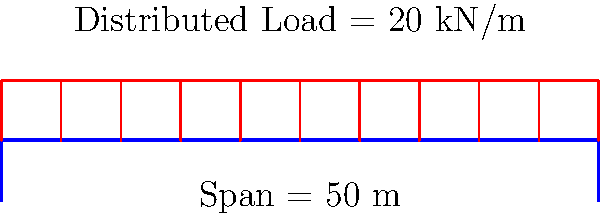As a former football coach, you're helping plan a parade route for your team's championship celebration. The route includes crossing a simple beam bridge. Given a bridge span of 50 meters and a uniform distributed load of 20 kN/m (including the weight of the bridge and the parade participants), what is the maximum bending moment at the center of the bridge? Let's approach this step-by-step:

1) For a simple beam bridge with a uniformly distributed load, the maximum bending moment occurs at the center of the span.

2) The formula for the maximum bending moment (M) in this case is:

   $$M = \frac{wL^2}{8}$$

   Where:
   w = distributed load (kN/m)
   L = span length (m)

3) We're given:
   w = 20 kN/m
   L = 50 m

4) Let's substitute these values into our formula:

   $$M = \frac{20 \cdot 50^2}{8}$$

5) Now, let's calculate:

   $$M = \frac{20 \cdot 2500}{8} = \frac{50000}{8} = 6250$$

6) Therefore, the maximum bending moment at the center of the bridge is 6250 kN·m.

This bending moment represents the internal force that the bridge must resist to prevent failure. It's crucial for ensuring the safety of your team and fans during the parade.
Answer: 6250 kN·m 